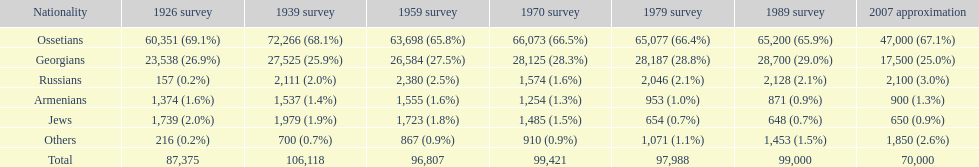Who is previous of the russians based on the list? Georgians. 